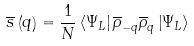<formula> <loc_0><loc_0><loc_500><loc_500>\overline { s } \left ( q \right ) = \frac { 1 } { N } \left \langle \Psi _ { L } \right | \overline { \rho } _ { - q } \overline { \rho } _ { q } \left | \Psi _ { L } \right \rangle</formula> 